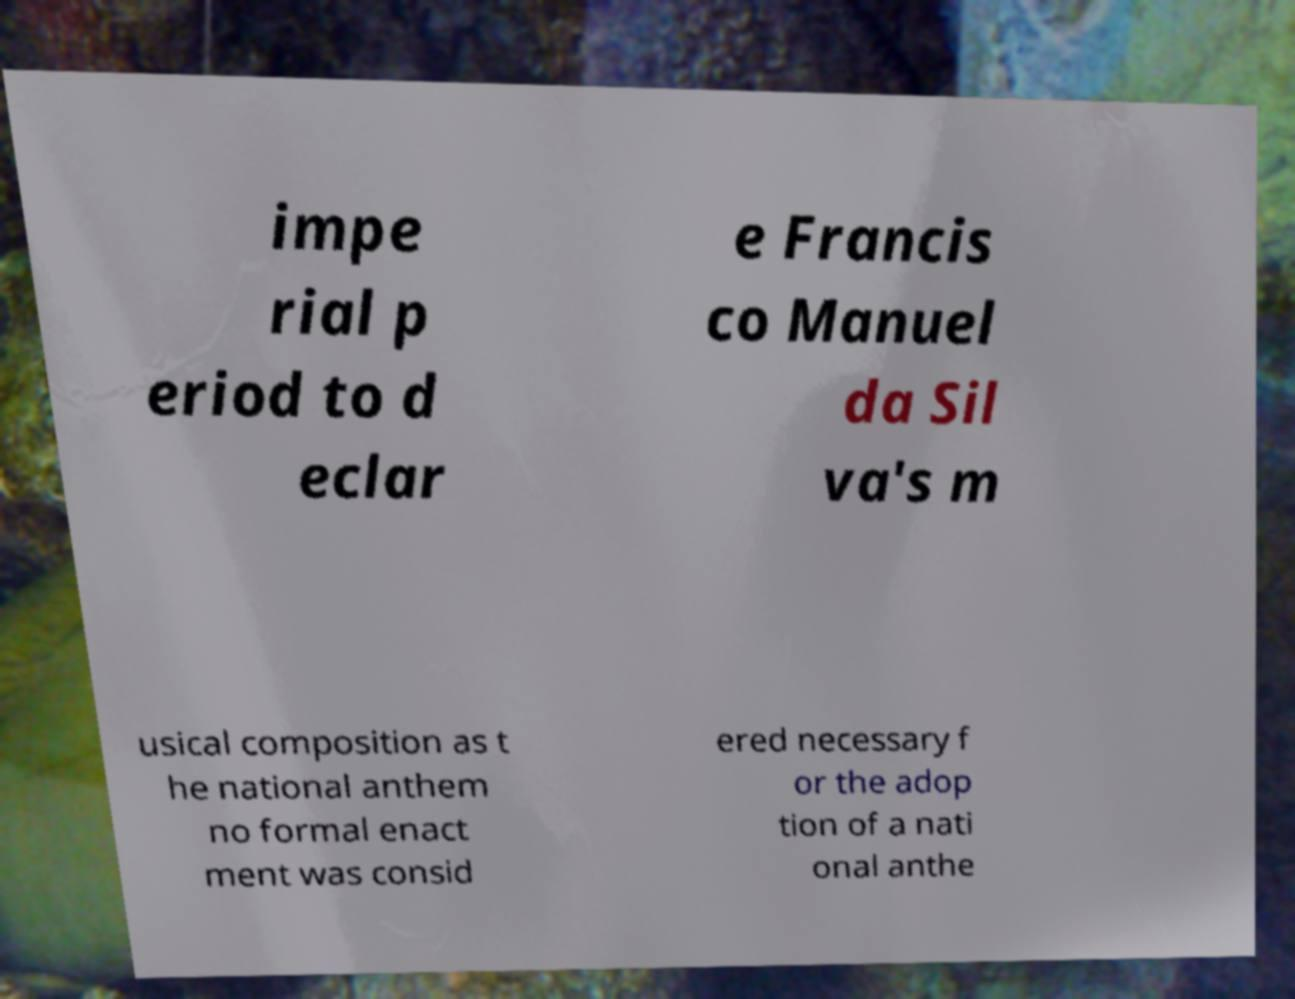There's text embedded in this image that I need extracted. Can you transcribe it verbatim? impe rial p eriod to d eclar e Francis co Manuel da Sil va's m usical composition as t he national anthem no formal enact ment was consid ered necessary f or the adop tion of a nati onal anthe 